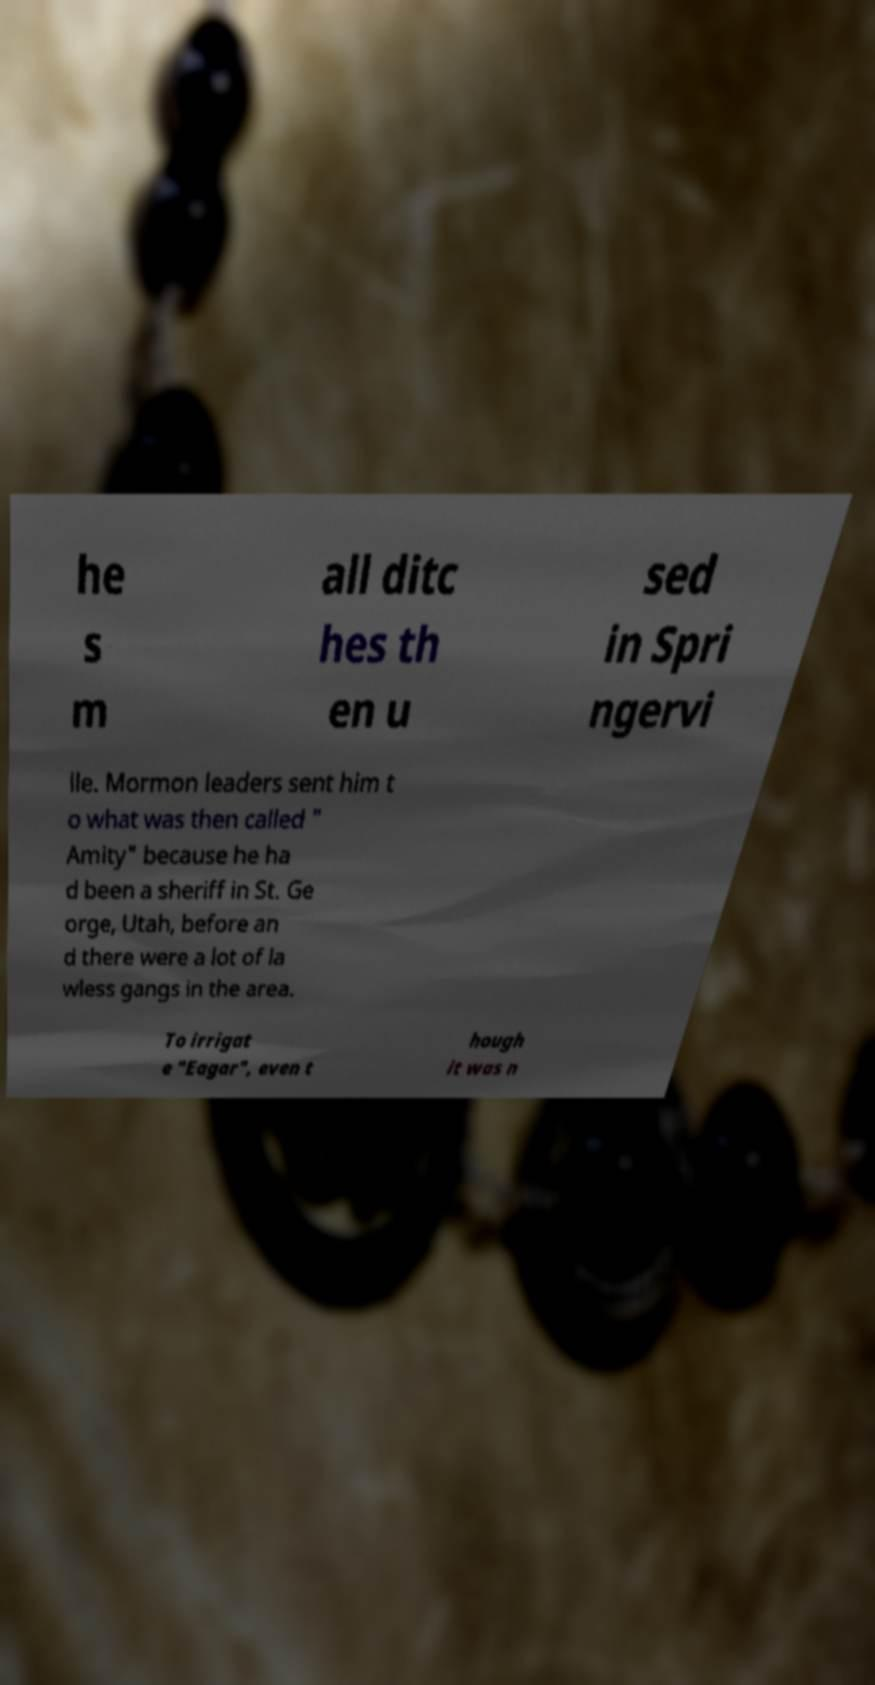Can you accurately transcribe the text from the provided image for me? he s m all ditc hes th en u sed in Spri ngervi lle. Mormon leaders sent him t o what was then called " Amity" because he ha d been a sheriff in St. Ge orge, Utah, before an d there were a lot of la wless gangs in the area. To irrigat e "Eagar", even t hough it was n 